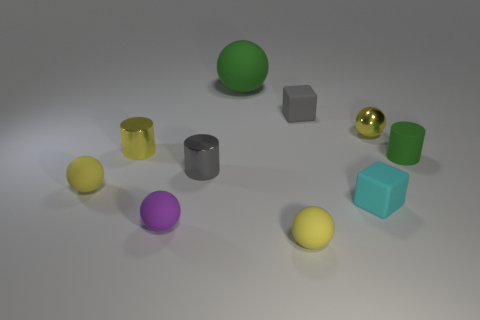Is there anything else that is the same size as the green sphere?
Your answer should be compact. No. Is the matte cylinder the same size as the green matte ball?
Offer a very short reply. No. Is the number of tiny shiny objects that are left of the small green cylinder the same as the number of small cylinders that are in front of the big rubber sphere?
Offer a very short reply. Yes. Are there any small matte cylinders?
Ensure brevity in your answer.  Yes. The yellow thing that is the same shape as the tiny green rubber thing is what size?
Ensure brevity in your answer.  Small. What size is the block behind the tiny gray metallic cylinder?
Make the answer very short. Small. Is the number of tiny cylinders that are behind the gray metallic object greater than the number of large spheres?
Your response must be concise. Yes. What is the shape of the small cyan thing?
Your answer should be compact. Cube. Do the rubber thing that is behind the gray matte thing and the small rubber cylinder in front of the tiny yellow metallic cylinder have the same color?
Offer a very short reply. Yes. Is the shape of the tiny green thing the same as the large green object?
Your response must be concise. No. 